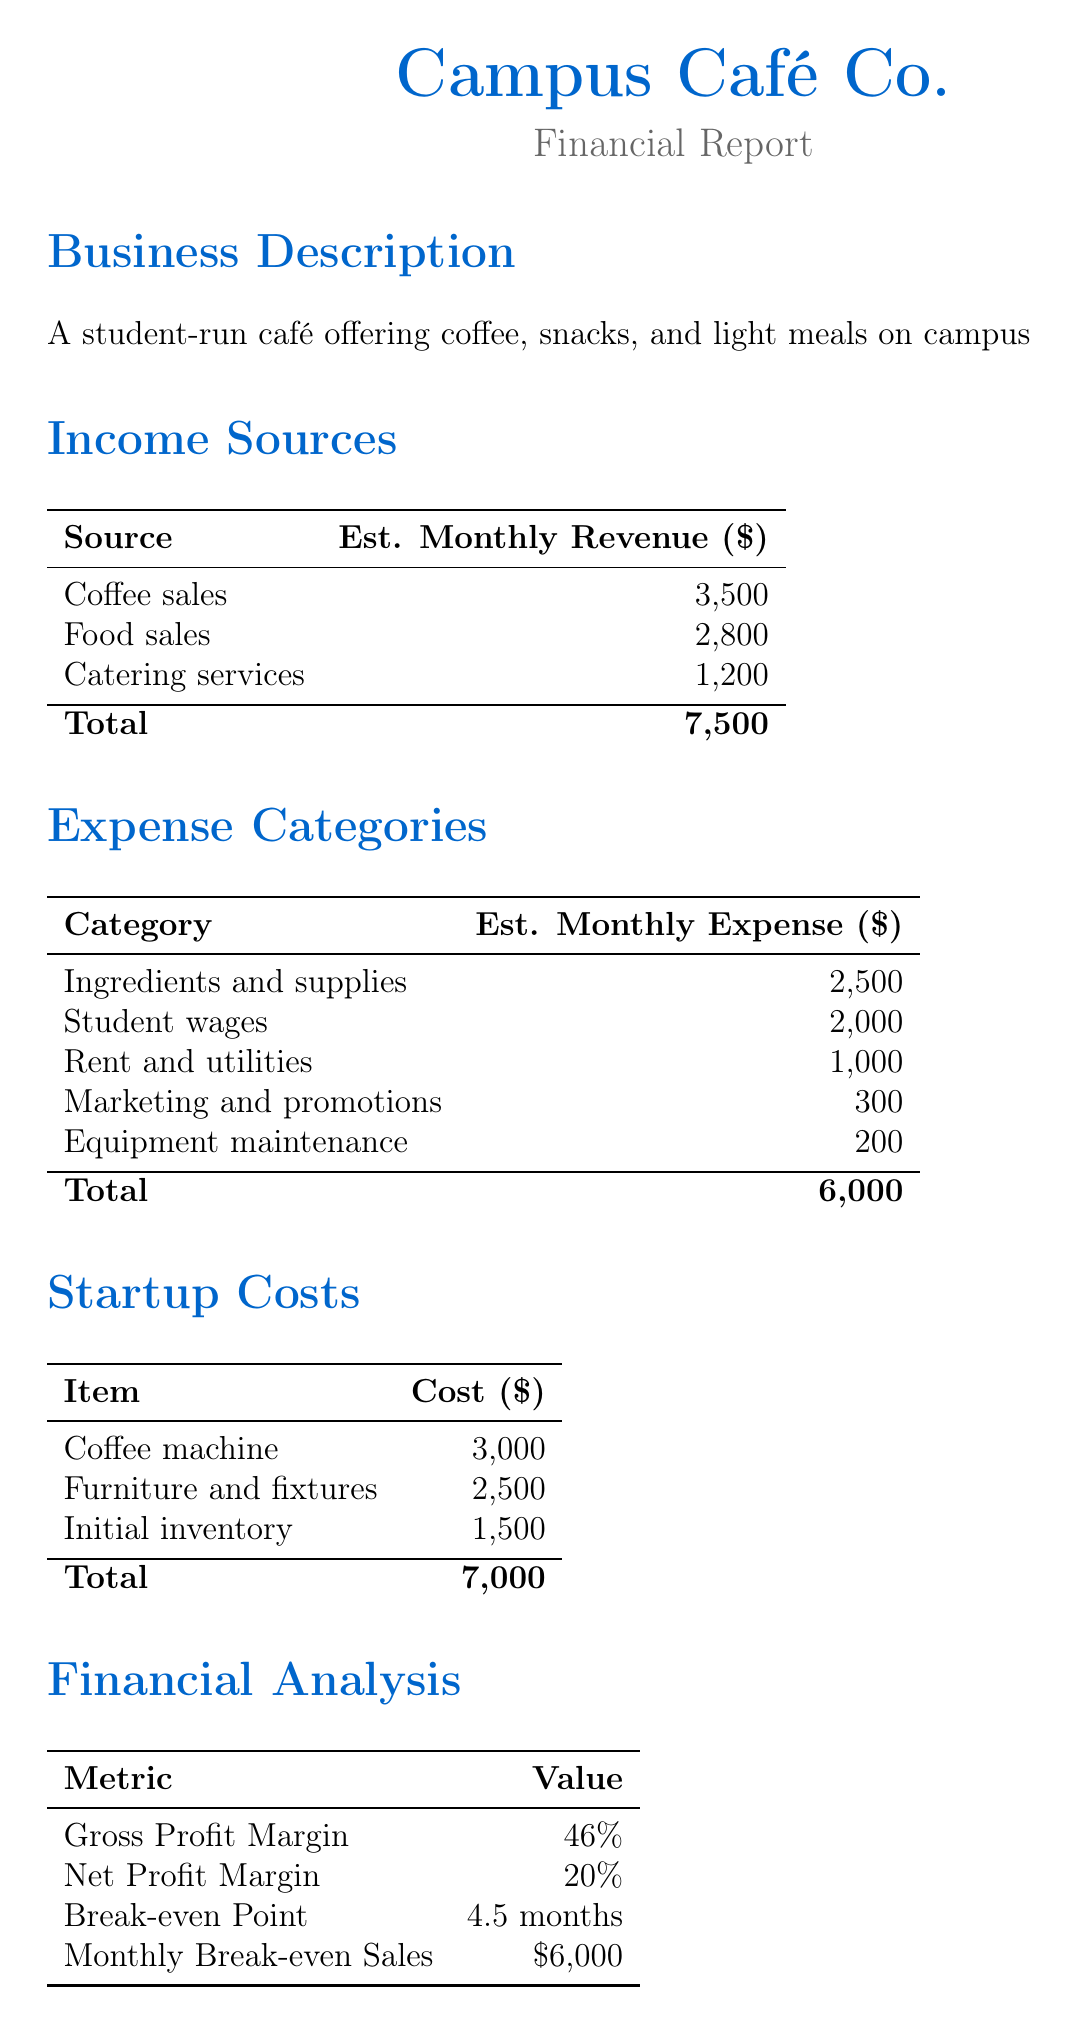What is the estimated monthly revenue from coffee sales? The estimated monthly revenue from coffee sales is specified in the income sources section of the document.
Answer: 3500 What are the total estimated monthly expenses? The total estimated monthly expenses are the sum of all expense categories in the document, which is 2500 + 2000 + 1000 + 300 + 200 = 6000.
Answer: 6000 What is the cost of the coffee machine? The cost of the coffee machine is listed under startup costs in the document.
Answer: 3000 What is the gross profit margin? The gross profit margin is found in the financial analysis section of the document.
Answer: 46% What is the break-even point? The break-even point is specified in the financial analysis section, indicating how long it will take to cover initial investment costs.
Answer: 4.5 months What is the projected growth for year 2? The projected growth for year 2 is included in the projected growth section of the document.
Answer: 15% How much is the estimated monthly revenue from catering services? The estimated monthly revenue from catering services is detailed in the income sources section.
Answer: 1200 What is the total cost for furniture and fixtures? The total cost for furniture and fixtures is outlined in the startup costs section of the document.
Answer: 2500 What category has the highest estimated monthly expense? The highest estimated monthly expense is determined by comparing all expense categories listed in the document.
Answer: Ingredients and supplies 